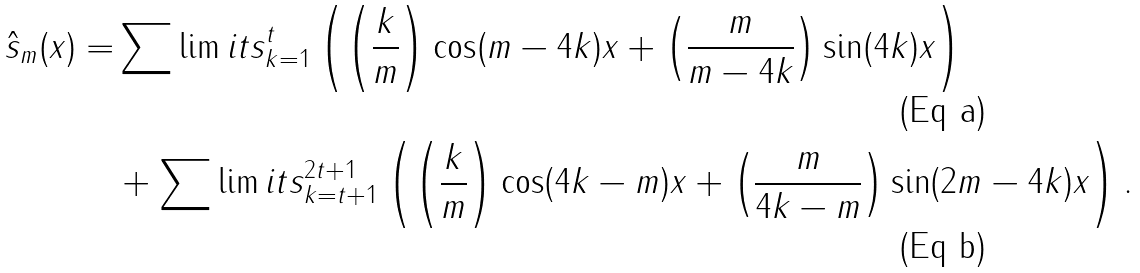Convert formula to latex. <formula><loc_0><loc_0><loc_500><loc_500>\hat { s } _ { m } ( x ) = & \sum \lim i t s _ { k = 1 } ^ { t } \left ( \left ( \frac { k } { m } \right ) \cos ( m - 4 k ) x + \left ( \frac { m } { m - 4 k } \right ) \sin ( 4 k ) x \right ) \\ & + \sum \lim i t s _ { k = t + 1 } ^ { 2 t + 1 } \left ( \left ( \frac { k } { m } \right ) \cos ( 4 k - m ) x + \left ( \frac { m } { 4 k - m } \right ) \sin ( 2 m - 4 k ) x \right ) .</formula> 